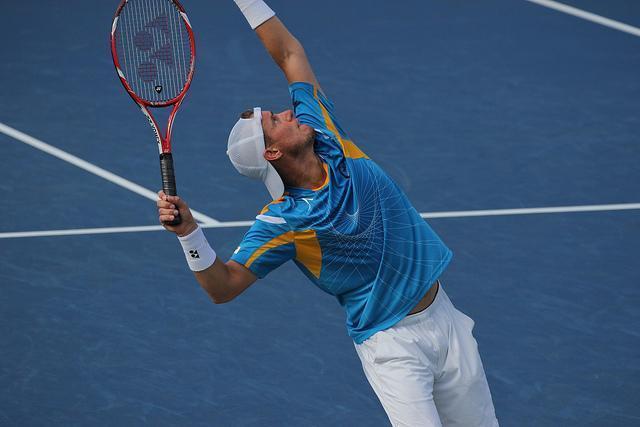How many bottles on the cutting board are uncorked?
Give a very brief answer. 0. 